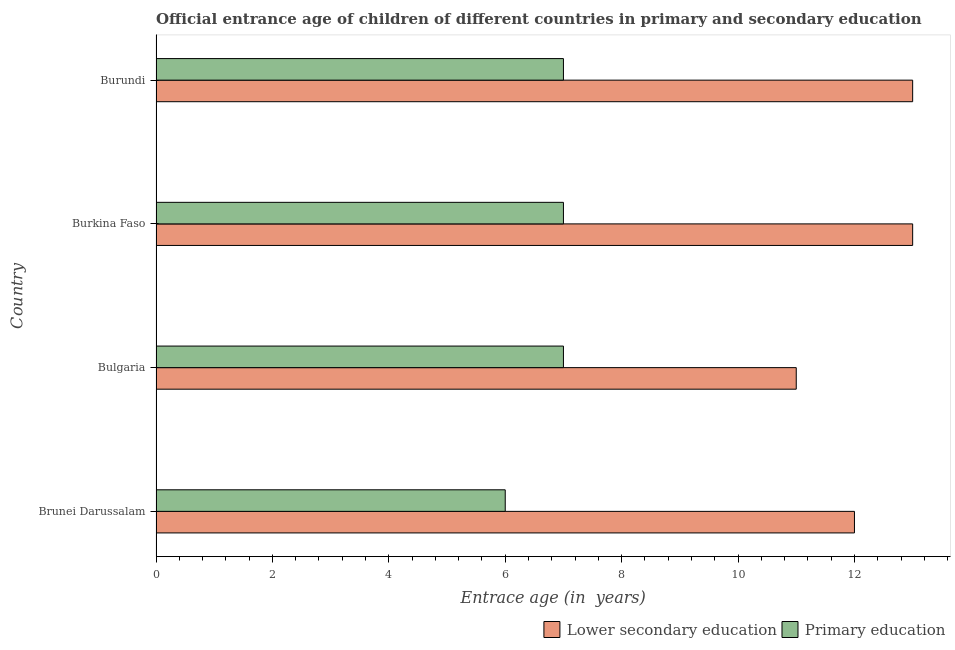How many different coloured bars are there?
Make the answer very short. 2. Are the number of bars per tick equal to the number of legend labels?
Provide a succinct answer. Yes. How many bars are there on the 2nd tick from the bottom?
Offer a terse response. 2. What is the label of the 2nd group of bars from the top?
Ensure brevity in your answer.  Burkina Faso. Across all countries, what is the maximum entrance age of chiildren in primary education?
Keep it short and to the point. 7. Across all countries, what is the minimum entrance age of children in lower secondary education?
Provide a short and direct response. 11. In which country was the entrance age of children in lower secondary education maximum?
Your answer should be very brief. Burkina Faso. What is the total entrance age of chiildren in primary education in the graph?
Your answer should be very brief. 27. What is the difference between the entrance age of chiildren in primary education in Brunei Darussalam and that in Burundi?
Give a very brief answer. -1. What is the average entrance age of children in lower secondary education per country?
Offer a very short reply. 12.25. What is the difference between the entrance age of children in lower secondary education and entrance age of chiildren in primary education in Burundi?
Make the answer very short. 6. In how many countries, is the entrance age of children in lower secondary education greater than 5.2 years?
Your response must be concise. 4. What is the ratio of the entrance age of chiildren in primary education in Bulgaria to that in Burkina Faso?
Your answer should be very brief. 1. Is the entrance age of chiildren in primary education in Brunei Darussalam less than that in Burkina Faso?
Give a very brief answer. Yes. What is the difference between the highest and the second highest entrance age of children in lower secondary education?
Your answer should be very brief. 0. What is the difference between the highest and the lowest entrance age of chiildren in primary education?
Your response must be concise. 1. Is the sum of the entrance age of children in lower secondary education in Brunei Darussalam and Bulgaria greater than the maximum entrance age of chiildren in primary education across all countries?
Your answer should be compact. Yes. What does the 2nd bar from the top in Brunei Darussalam represents?
Keep it short and to the point. Lower secondary education. What does the 2nd bar from the bottom in Brunei Darussalam represents?
Ensure brevity in your answer.  Primary education. How many bars are there?
Your answer should be compact. 8. Are all the bars in the graph horizontal?
Your answer should be compact. Yes. What is the difference between two consecutive major ticks on the X-axis?
Your answer should be very brief. 2. Are the values on the major ticks of X-axis written in scientific E-notation?
Your answer should be very brief. No. Does the graph contain any zero values?
Provide a succinct answer. No. How many legend labels are there?
Your response must be concise. 2. What is the title of the graph?
Provide a succinct answer. Official entrance age of children of different countries in primary and secondary education. What is the label or title of the X-axis?
Your answer should be compact. Entrace age (in  years). What is the Entrace age (in  years) of Lower secondary education in Brunei Darussalam?
Ensure brevity in your answer.  12. What is the Entrace age (in  years) in Primary education in Brunei Darussalam?
Provide a succinct answer. 6. What is the Entrace age (in  years) in Lower secondary education in Bulgaria?
Ensure brevity in your answer.  11. What is the Entrace age (in  years) in Primary education in Bulgaria?
Ensure brevity in your answer.  7. What is the Entrace age (in  years) of Lower secondary education in Burkina Faso?
Offer a very short reply. 13. What is the Entrace age (in  years) of Primary education in Burkina Faso?
Offer a very short reply. 7. Across all countries, what is the maximum Entrace age (in  years) in Primary education?
Provide a short and direct response. 7. Across all countries, what is the minimum Entrace age (in  years) of Lower secondary education?
Make the answer very short. 11. Across all countries, what is the minimum Entrace age (in  years) in Primary education?
Your answer should be compact. 6. What is the total Entrace age (in  years) in Primary education in the graph?
Your response must be concise. 27. What is the difference between the Entrace age (in  years) in Primary education in Brunei Darussalam and that in Burkina Faso?
Keep it short and to the point. -1. What is the difference between the Entrace age (in  years) in Lower secondary education in Bulgaria and that in Burkina Faso?
Provide a succinct answer. -2. What is the difference between the Entrace age (in  years) in Primary education in Bulgaria and that in Burundi?
Give a very brief answer. 0. What is the difference between the Entrace age (in  years) of Lower secondary education in Brunei Darussalam and the Entrace age (in  years) of Primary education in Burkina Faso?
Your answer should be very brief. 5. What is the average Entrace age (in  years) in Lower secondary education per country?
Keep it short and to the point. 12.25. What is the average Entrace age (in  years) of Primary education per country?
Keep it short and to the point. 6.75. What is the difference between the Entrace age (in  years) of Lower secondary education and Entrace age (in  years) of Primary education in Brunei Darussalam?
Your response must be concise. 6. What is the difference between the Entrace age (in  years) in Lower secondary education and Entrace age (in  years) in Primary education in Bulgaria?
Keep it short and to the point. 4. What is the difference between the Entrace age (in  years) in Lower secondary education and Entrace age (in  years) in Primary education in Burkina Faso?
Your response must be concise. 6. What is the difference between the Entrace age (in  years) of Lower secondary education and Entrace age (in  years) of Primary education in Burundi?
Give a very brief answer. 6. What is the ratio of the Entrace age (in  years) in Lower secondary education in Brunei Darussalam to that in Bulgaria?
Offer a terse response. 1.09. What is the ratio of the Entrace age (in  years) in Primary education in Brunei Darussalam to that in Burkina Faso?
Your answer should be compact. 0.86. What is the ratio of the Entrace age (in  years) of Lower secondary education in Brunei Darussalam to that in Burundi?
Your answer should be compact. 0.92. What is the ratio of the Entrace age (in  years) in Lower secondary education in Bulgaria to that in Burkina Faso?
Keep it short and to the point. 0.85. What is the ratio of the Entrace age (in  years) in Lower secondary education in Bulgaria to that in Burundi?
Your response must be concise. 0.85. What is the difference between the highest and the second highest Entrace age (in  years) of Primary education?
Your answer should be compact. 0. 